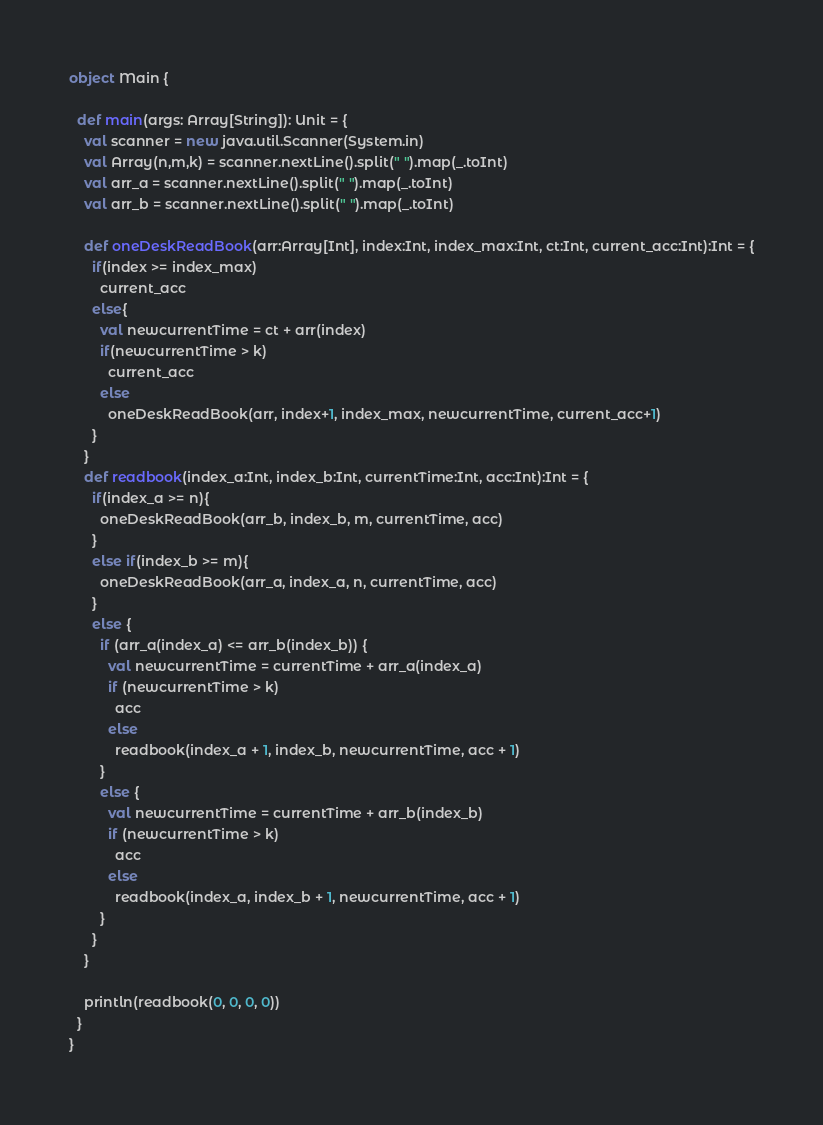Convert code to text. <code><loc_0><loc_0><loc_500><loc_500><_Scala_>object Main {

  def main(args: Array[String]): Unit = {
    val scanner = new java.util.Scanner(System.in)
    val Array(n,m,k) = scanner.nextLine().split(" ").map(_.toInt)
    val arr_a = scanner.nextLine().split(" ").map(_.toInt)
    val arr_b = scanner.nextLine().split(" ").map(_.toInt)

    def oneDeskReadBook(arr:Array[Int], index:Int, index_max:Int, ct:Int, current_acc:Int):Int = {
      if(index >= index_max)
        current_acc
      else{
        val newcurrentTime = ct + arr(index)
        if(newcurrentTime > k)
          current_acc
        else
          oneDeskReadBook(arr, index+1, index_max, newcurrentTime, current_acc+1)
      }
    }
    def readbook(index_a:Int, index_b:Int, currentTime:Int, acc:Int):Int = {
      if(index_a >= n){
        oneDeskReadBook(arr_b, index_b, m, currentTime, acc)
      }
      else if(index_b >= m){
        oneDeskReadBook(arr_a, index_a, n, currentTime, acc)
      }
      else {
        if (arr_a(index_a) <= arr_b(index_b)) {
          val newcurrentTime = currentTime + arr_a(index_a)
          if (newcurrentTime > k)
            acc
          else
            readbook(index_a + 1, index_b, newcurrentTime, acc + 1)
        }
        else {
          val newcurrentTime = currentTime + arr_b(index_b)
          if (newcurrentTime > k)
            acc
          else
            readbook(index_a, index_b + 1, newcurrentTime, acc + 1)
        }
      }
    }

    println(readbook(0, 0, 0, 0))
  }
}
</code> 